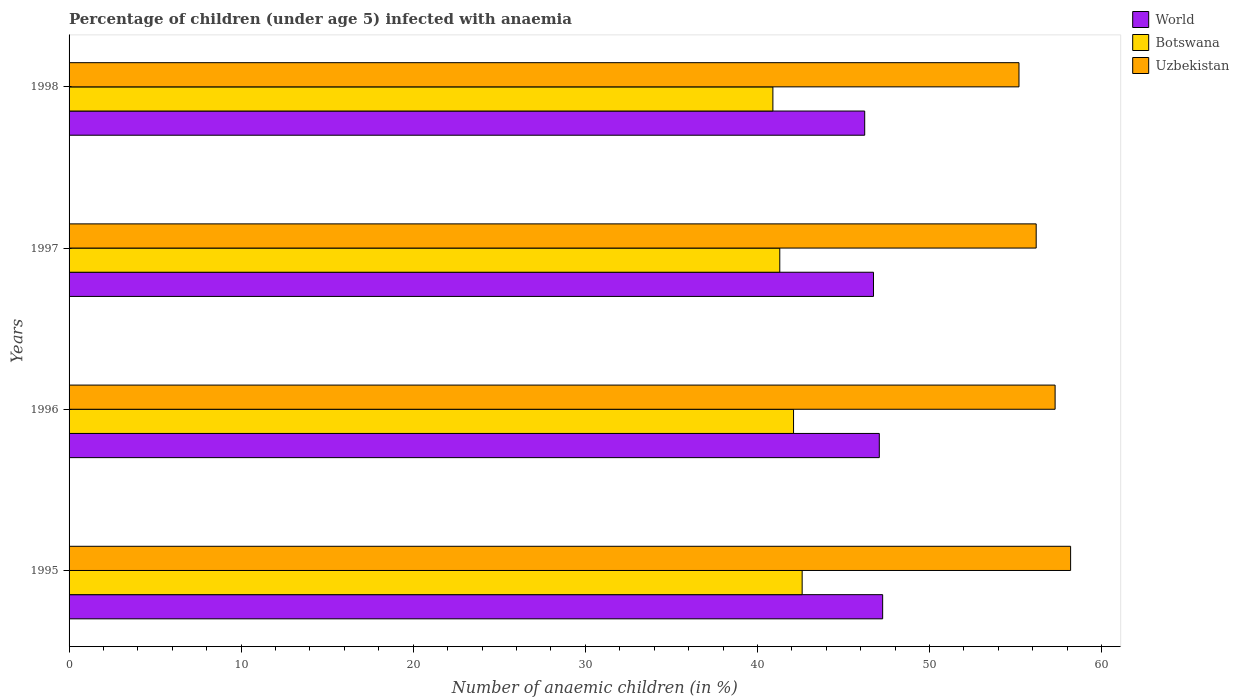How many different coloured bars are there?
Offer a very short reply. 3. How many bars are there on the 1st tick from the top?
Keep it short and to the point. 3. How many bars are there on the 2nd tick from the bottom?
Ensure brevity in your answer.  3. In how many cases, is the number of bars for a given year not equal to the number of legend labels?
Your response must be concise. 0. What is the percentage of children infected with anaemia in in World in 1997?
Your answer should be very brief. 46.75. Across all years, what is the maximum percentage of children infected with anaemia in in Botswana?
Make the answer very short. 42.6. Across all years, what is the minimum percentage of children infected with anaemia in in World?
Give a very brief answer. 46.24. In which year was the percentage of children infected with anaemia in in Botswana maximum?
Offer a terse response. 1995. In which year was the percentage of children infected with anaemia in in World minimum?
Ensure brevity in your answer.  1998. What is the total percentage of children infected with anaemia in in Uzbekistan in the graph?
Give a very brief answer. 226.9. What is the difference between the percentage of children infected with anaemia in in World in 1995 and that in 1997?
Give a very brief answer. 0.53. What is the difference between the percentage of children infected with anaemia in in World in 1996 and the percentage of children infected with anaemia in in Uzbekistan in 1995?
Your answer should be very brief. -11.12. What is the average percentage of children infected with anaemia in in Uzbekistan per year?
Give a very brief answer. 56.72. In the year 1996, what is the difference between the percentage of children infected with anaemia in in Botswana and percentage of children infected with anaemia in in Uzbekistan?
Ensure brevity in your answer.  -15.2. In how many years, is the percentage of children infected with anaemia in in Uzbekistan greater than 14 %?
Your answer should be compact. 4. What is the ratio of the percentage of children infected with anaemia in in Uzbekistan in 1995 to that in 1997?
Offer a terse response. 1.04. Is the percentage of children infected with anaemia in in World in 1997 less than that in 1998?
Offer a terse response. No. What is the difference between the highest and the second highest percentage of children infected with anaemia in in Uzbekistan?
Offer a very short reply. 0.9. What is the difference between the highest and the lowest percentage of children infected with anaemia in in World?
Your answer should be compact. 1.04. Is the sum of the percentage of children infected with anaemia in in Botswana in 1996 and 1997 greater than the maximum percentage of children infected with anaemia in in World across all years?
Offer a very short reply. Yes. What does the 2nd bar from the top in 1996 represents?
Give a very brief answer. Botswana. What does the 2nd bar from the bottom in 1998 represents?
Keep it short and to the point. Botswana. Is it the case that in every year, the sum of the percentage of children infected with anaemia in in World and percentage of children infected with anaemia in in Uzbekistan is greater than the percentage of children infected with anaemia in in Botswana?
Offer a very short reply. Yes. How many bars are there?
Your answer should be compact. 12. Are all the bars in the graph horizontal?
Your answer should be compact. Yes. How are the legend labels stacked?
Keep it short and to the point. Vertical. What is the title of the graph?
Your answer should be very brief. Percentage of children (under age 5) infected with anaemia. What is the label or title of the X-axis?
Your response must be concise. Number of anaemic children (in %). What is the label or title of the Y-axis?
Your response must be concise. Years. What is the Number of anaemic children (in %) of World in 1995?
Offer a terse response. 47.28. What is the Number of anaemic children (in %) of Botswana in 1995?
Give a very brief answer. 42.6. What is the Number of anaemic children (in %) in Uzbekistan in 1995?
Provide a short and direct response. 58.2. What is the Number of anaemic children (in %) of World in 1996?
Your answer should be very brief. 47.08. What is the Number of anaemic children (in %) of Botswana in 1996?
Ensure brevity in your answer.  42.1. What is the Number of anaemic children (in %) in Uzbekistan in 1996?
Make the answer very short. 57.3. What is the Number of anaemic children (in %) in World in 1997?
Provide a succinct answer. 46.75. What is the Number of anaemic children (in %) of Botswana in 1997?
Keep it short and to the point. 41.3. What is the Number of anaemic children (in %) of Uzbekistan in 1997?
Your response must be concise. 56.2. What is the Number of anaemic children (in %) in World in 1998?
Your answer should be compact. 46.24. What is the Number of anaemic children (in %) of Botswana in 1998?
Keep it short and to the point. 40.9. What is the Number of anaemic children (in %) of Uzbekistan in 1998?
Give a very brief answer. 55.2. Across all years, what is the maximum Number of anaemic children (in %) of World?
Provide a succinct answer. 47.28. Across all years, what is the maximum Number of anaemic children (in %) of Botswana?
Provide a short and direct response. 42.6. Across all years, what is the maximum Number of anaemic children (in %) of Uzbekistan?
Ensure brevity in your answer.  58.2. Across all years, what is the minimum Number of anaemic children (in %) in World?
Your answer should be compact. 46.24. Across all years, what is the minimum Number of anaemic children (in %) of Botswana?
Give a very brief answer. 40.9. Across all years, what is the minimum Number of anaemic children (in %) of Uzbekistan?
Ensure brevity in your answer.  55.2. What is the total Number of anaemic children (in %) in World in the graph?
Provide a succinct answer. 187.34. What is the total Number of anaemic children (in %) in Botswana in the graph?
Provide a succinct answer. 166.9. What is the total Number of anaemic children (in %) of Uzbekistan in the graph?
Your response must be concise. 226.9. What is the difference between the Number of anaemic children (in %) in World in 1995 and that in 1996?
Offer a terse response. 0.19. What is the difference between the Number of anaemic children (in %) of Uzbekistan in 1995 and that in 1996?
Keep it short and to the point. 0.9. What is the difference between the Number of anaemic children (in %) of World in 1995 and that in 1997?
Make the answer very short. 0.53. What is the difference between the Number of anaemic children (in %) in Botswana in 1995 and that in 1997?
Your response must be concise. 1.3. What is the difference between the Number of anaemic children (in %) in Uzbekistan in 1995 and that in 1997?
Keep it short and to the point. 2. What is the difference between the Number of anaemic children (in %) of World in 1995 and that in 1998?
Offer a terse response. 1.04. What is the difference between the Number of anaemic children (in %) of Botswana in 1995 and that in 1998?
Make the answer very short. 1.7. What is the difference between the Number of anaemic children (in %) of Uzbekistan in 1995 and that in 1998?
Offer a terse response. 3. What is the difference between the Number of anaemic children (in %) in World in 1996 and that in 1997?
Provide a short and direct response. 0.34. What is the difference between the Number of anaemic children (in %) of Uzbekistan in 1996 and that in 1997?
Provide a short and direct response. 1.1. What is the difference between the Number of anaemic children (in %) in World in 1996 and that in 1998?
Provide a succinct answer. 0.85. What is the difference between the Number of anaemic children (in %) in World in 1997 and that in 1998?
Ensure brevity in your answer.  0.51. What is the difference between the Number of anaemic children (in %) of World in 1995 and the Number of anaemic children (in %) of Botswana in 1996?
Provide a short and direct response. 5.18. What is the difference between the Number of anaemic children (in %) of World in 1995 and the Number of anaemic children (in %) of Uzbekistan in 1996?
Provide a succinct answer. -10.02. What is the difference between the Number of anaemic children (in %) of Botswana in 1995 and the Number of anaemic children (in %) of Uzbekistan in 1996?
Keep it short and to the point. -14.7. What is the difference between the Number of anaemic children (in %) in World in 1995 and the Number of anaemic children (in %) in Botswana in 1997?
Your answer should be very brief. 5.98. What is the difference between the Number of anaemic children (in %) in World in 1995 and the Number of anaemic children (in %) in Uzbekistan in 1997?
Offer a terse response. -8.92. What is the difference between the Number of anaemic children (in %) of World in 1995 and the Number of anaemic children (in %) of Botswana in 1998?
Ensure brevity in your answer.  6.38. What is the difference between the Number of anaemic children (in %) in World in 1995 and the Number of anaemic children (in %) in Uzbekistan in 1998?
Keep it short and to the point. -7.92. What is the difference between the Number of anaemic children (in %) of World in 1996 and the Number of anaemic children (in %) of Botswana in 1997?
Ensure brevity in your answer.  5.78. What is the difference between the Number of anaemic children (in %) of World in 1996 and the Number of anaemic children (in %) of Uzbekistan in 1997?
Offer a terse response. -9.12. What is the difference between the Number of anaemic children (in %) in Botswana in 1996 and the Number of anaemic children (in %) in Uzbekistan in 1997?
Keep it short and to the point. -14.1. What is the difference between the Number of anaemic children (in %) in World in 1996 and the Number of anaemic children (in %) in Botswana in 1998?
Make the answer very short. 6.18. What is the difference between the Number of anaemic children (in %) in World in 1996 and the Number of anaemic children (in %) in Uzbekistan in 1998?
Make the answer very short. -8.12. What is the difference between the Number of anaemic children (in %) of Botswana in 1996 and the Number of anaemic children (in %) of Uzbekistan in 1998?
Offer a very short reply. -13.1. What is the difference between the Number of anaemic children (in %) of World in 1997 and the Number of anaemic children (in %) of Botswana in 1998?
Offer a very short reply. 5.85. What is the difference between the Number of anaemic children (in %) of World in 1997 and the Number of anaemic children (in %) of Uzbekistan in 1998?
Make the answer very short. -8.45. What is the average Number of anaemic children (in %) in World per year?
Ensure brevity in your answer.  46.84. What is the average Number of anaemic children (in %) of Botswana per year?
Offer a very short reply. 41.73. What is the average Number of anaemic children (in %) of Uzbekistan per year?
Give a very brief answer. 56.73. In the year 1995, what is the difference between the Number of anaemic children (in %) in World and Number of anaemic children (in %) in Botswana?
Give a very brief answer. 4.68. In the year 1995, what is the difference between the Number of anaemic children (in %) of World and Number of anaemic children (in %) of Uzbekistan?
Your response must be concise. -10.92. In the year 1995, what is the difference between the Number of anaemic children (in %) in Botswana and Number of anaemic children (in %) in Uzbekistan?
Your answer should be very brief. -15.6. In the year 1996, what is the difference between the Number of anaemic children (in %) of World and Number of anaemic children (in %) of Botswana?
Your response must be concise. 4.98. In the year 1996, what is the difference between the Number of anaemic children (in %) in World and Number of anaemic children (in %) in Uzbekistan?
Ensure brevity in your answer.  -10.22. In the year 1996, what is the difference between the Number of anaemic children (in %) of Botswana and Number of anaemic children (in %) of Uzbekistan?
Keep it short and to the point. -15.2. In the year 1997, what is the difference between the Number of anaemic children (in %) in World and Number of anaemic children (in %) in Botswana?
Give a very brief answer. 5.45. In the year 1997, what is the difference between the Number of anaemic children (in %) of World and Number of anaemic children (in %) of Uzbekistan?
Your response must be concise. -9.45. In the year 1997, what is the difference between the Number of anaemic children (in %) in Botswana and Number of anaemic children (in %) in Uzbekistan?
Give a very brief answer. -14.9. In the year 1998, what is the difference between the Number of anaemic children (in %) of World and Number of anaemic children (in %) of Botswana?
Your answer should be compact. 5.34. In the year 1998, what is the difference between the Number of anaemic children (in %) in World and Number of anaemic children (in %) in Uzbekistan?
Offer a very short reply. -8.96. In the year 1998, what is the difference between the Number of anaemic children (in %) of Botswana and Number of anaemic children (in %) of Uzbekistan?
Make the answer very short. -14.3. What is the ratio of the Number of anaemic children (in %) of World in 1995 to that in 1996?
Your response must be concise. 1. What is the ratio of the Number of anaemic children (in %) of Botswana in 1995 to that in 1996?
Your response must be concise. 1.01. What is the ratio of the Number of anaemic children (in %) of Uzbekistan in 1995 to that in 1996?
Keep it short and to the point. 1.02. What is the ratio of the Number of anaemic children (in %) of World in 1995 to that in 1997?
Offer a very short reply. 1.01. What is the ratio of the Number of anaemic children (in %) of Botswana in 1995 to that in 1997?
Provide a succinct answer. 1.03. What is the ratio of the Number of anaemic children (in %) in Uzbekistan in 1995 to that in 1997?
Make the answer very short. 1.04. What is the ratio of the Number of anaemic children (in %) of World in 1995 to that in 1998?
Give a very brief answer. 1.02. What is the ratio of the Number of anaemic children (in %) of Botswana in 1995 to that in 1998?
Your answer should be very brief. 1.04. What is the ratio of the Number of anaemic children (in %) in Uzbekistan in 1995 to that in 1998?
Your answer should be very brief. 1.05. What is the ratio of the Number of anaemic children (in %) of Botswana in 1996 to that in 1997?
Your response must be concise. 1.02. What is the ratio of the Number of anaemic children (in %) of Uzbekistan in 1996 to that in 1997?
Provide a succinct answer. 1.02. What is the ratio of the Number of anaemic children (in %) in World in 1996 to that in 1998?
Make the answer very short. 1.02. What is the ratio of the Number of anaemic children (in %) in Botswana in 1996 to that in 1998?
Your answer should be compact. 1.03. What is the ratio of the Number of anaemic children (in %) of Uzbekistan in 1996 to that in 1998?
Your answer should be very brief. 1.04. What is the ratio of the Number of anaemic children (in %) in World in 1997 to that in 1998?
Offer a very short reply. 1.01. What is the ratio of the Number of anaemic children (in %) in Botswana in 1997 to that in 1998?
Provide a short and direct response. 1.01. What is the ratio of the Number of anaemic children (in %) of Uzbekistan in 1997 to that in 1998?
Provide a succinct answer. 1.02. What is the difference between the highest and the second highest Number of anaemic children (in %) in World?
Your answer should be compact. 0.19. What is the difference between the highest and the second highest Number of anaemic children (in %) in Botswana?
Offer a terse response. 0.5. What is the difference between the highest and the lowest Number of anaemic children (in %) of World?
Keep it short and to the point. 1.04. What is the difference between the highest and the lowest Number of anaemic children (in %) in Uzbekistan?
Your response must be concise. 3. 